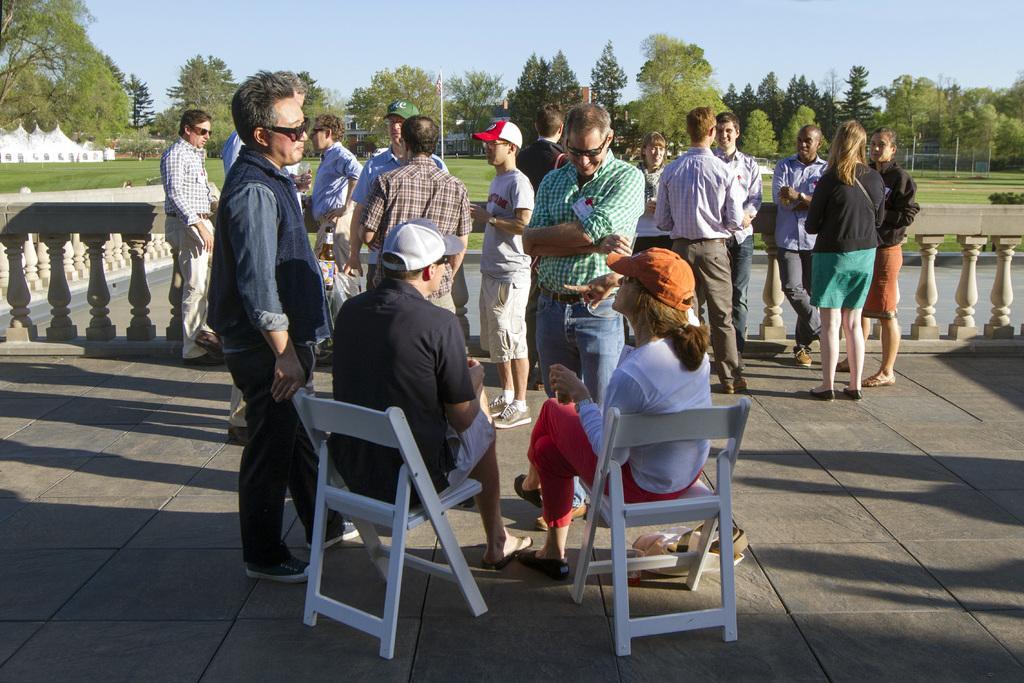How would you summarize this image in a sentence or two? A person wearing a black t shirt, goggles, cap is sitting on a chair. A lady wearing a white t shirt red pants is sitting on a chair also wearing a cap. In the background there are many persons standing. There is a railings. In the background there are many trees, sky, grass lawn and water. 